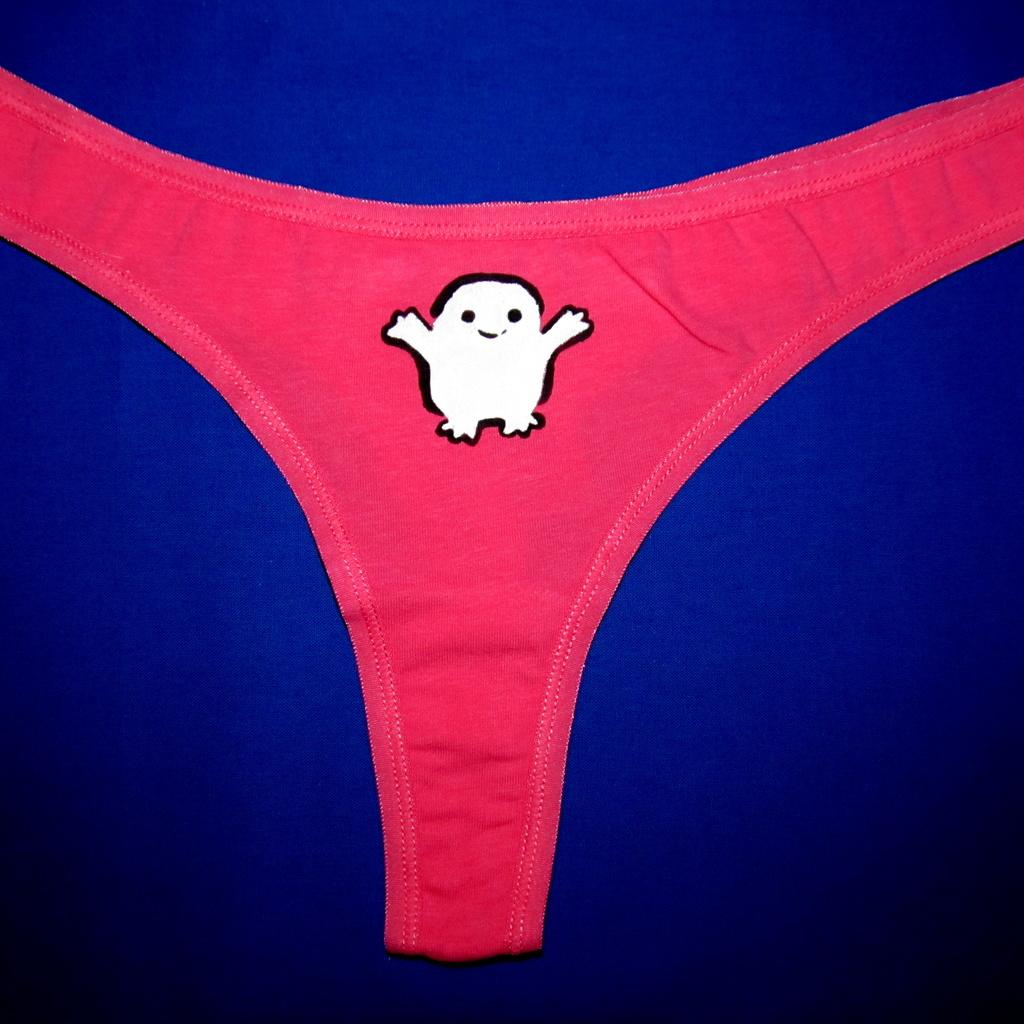What type of clothing item is in the image? There is a red color undergarment in the image. What design is on the undergarment? There is a cartoon picture on the undergarment. On what surface is the undergarment placed? The undergarment is on a blue color surface. What type of gold lock is securing the undergarment in the image? There is no gold lock present in the image; the undergarment is simply placed on a blue color surface. 